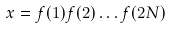<formula> <loc_0><loc_0><loc_500><loc_500>x = f ( 1 ) f ( 2 ) \dots f ( 2 N )</formula> 